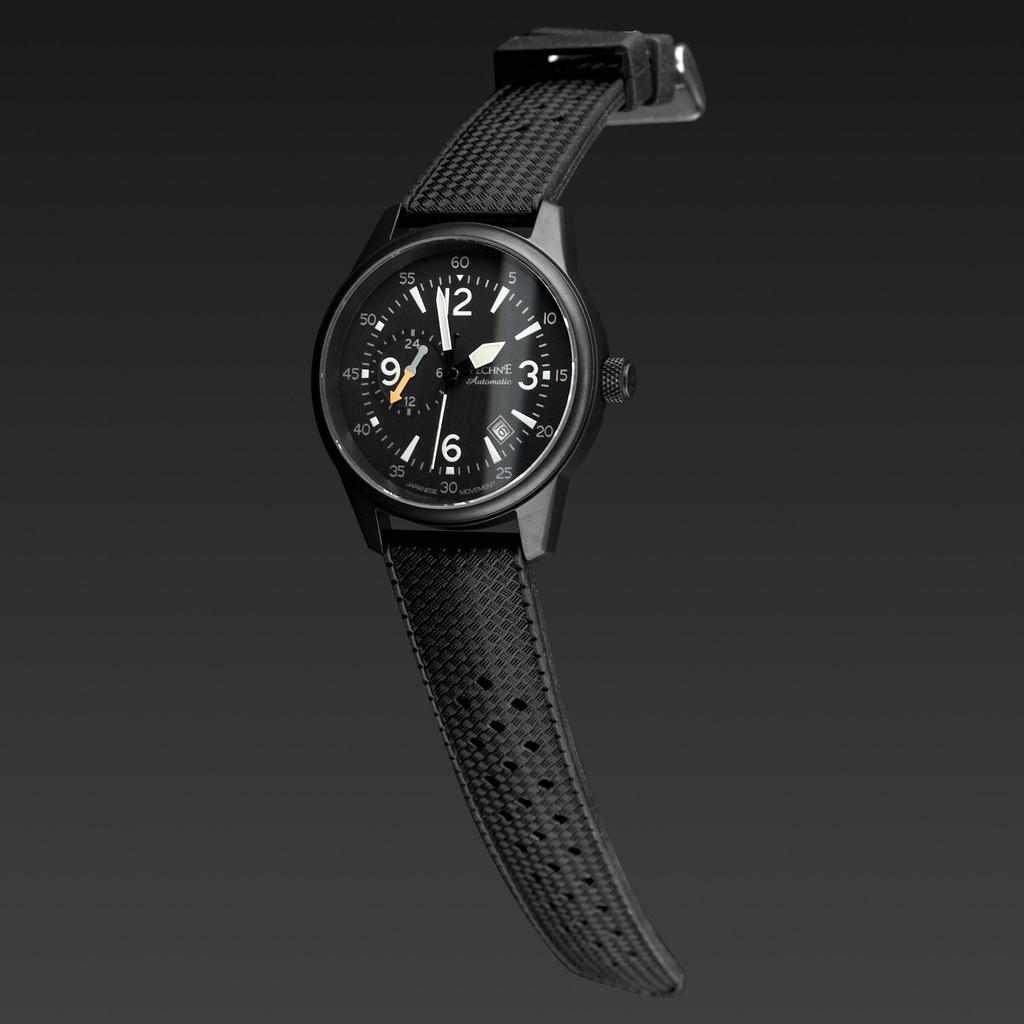What hour is approaching?
Make the answer very short. 2. 